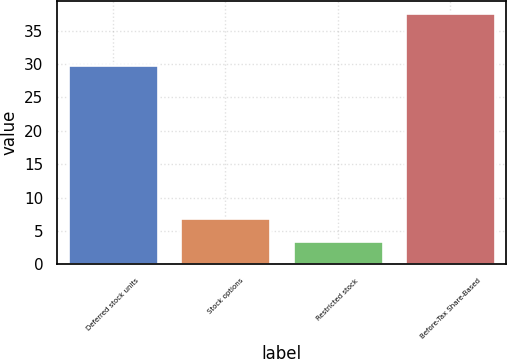Convert chart. <chart><loc_0><loc_0><loc_500><loc_500><bar_chart><fcel>Deferred stock units<fcel>Stock options<fcel>Restricted stock<fcel>Before-Tax Share-Based<nl><fcel>29.9<fcel>6.91<fcel>3.5<fcel>37.6<nl></chart> 